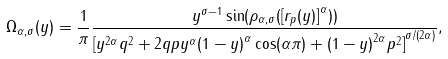Convert formula to latex. <formula><loc_0><loc_0><loc_500><loc_500>\Omega _ { \alpha , \sigma } ( y ) = \frac { 1 } { \pi } \frac { y ^ { \sigma - 1 } \sin ( \rho _ { \alpha , \sigma } ( { [ r _ { p } ( y ) ] } ^ { \alpha } ) ) } { { [ y ^ { 2 \alpha } q ^ { 2 } + 2 q p y ^ { \alpha } { ( 1 - y ) } ^ { \alpha } \cos ( \alpha \pi ) + { ( 1 - y ) } ^ { 2 \alpha } p ^ { 2 } ] } ^ { { \sigma } / ( { 2 \alpha } ) } } ,</formula> 